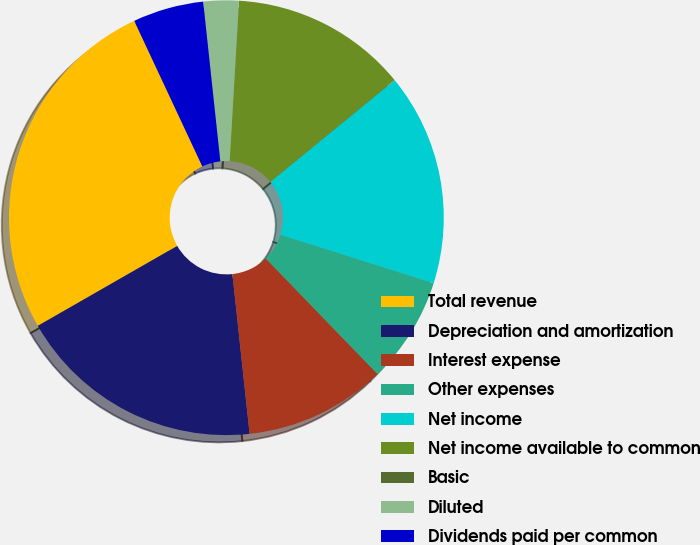Convert chart. <chart><loc_0><loc_0><loc_500><loc_500><pie_chart><fcel>Total revenue<fcel>Depreciation and amortization<fcel>Interest expense<fcel>Other expenses<fcel>Net income<fcel>Net income available to common<fcel>Basic<fcel>Diluted<fcel>Dividends paid per common<nl><fcel>26.32%<fcel>18.42%<fcel>10.53%<fcel>7.89%<fcel>15.79%<fcel>13.16%<fcel>0.0%<fcel>2.63%<fcel>5.26%<nl></chart> 